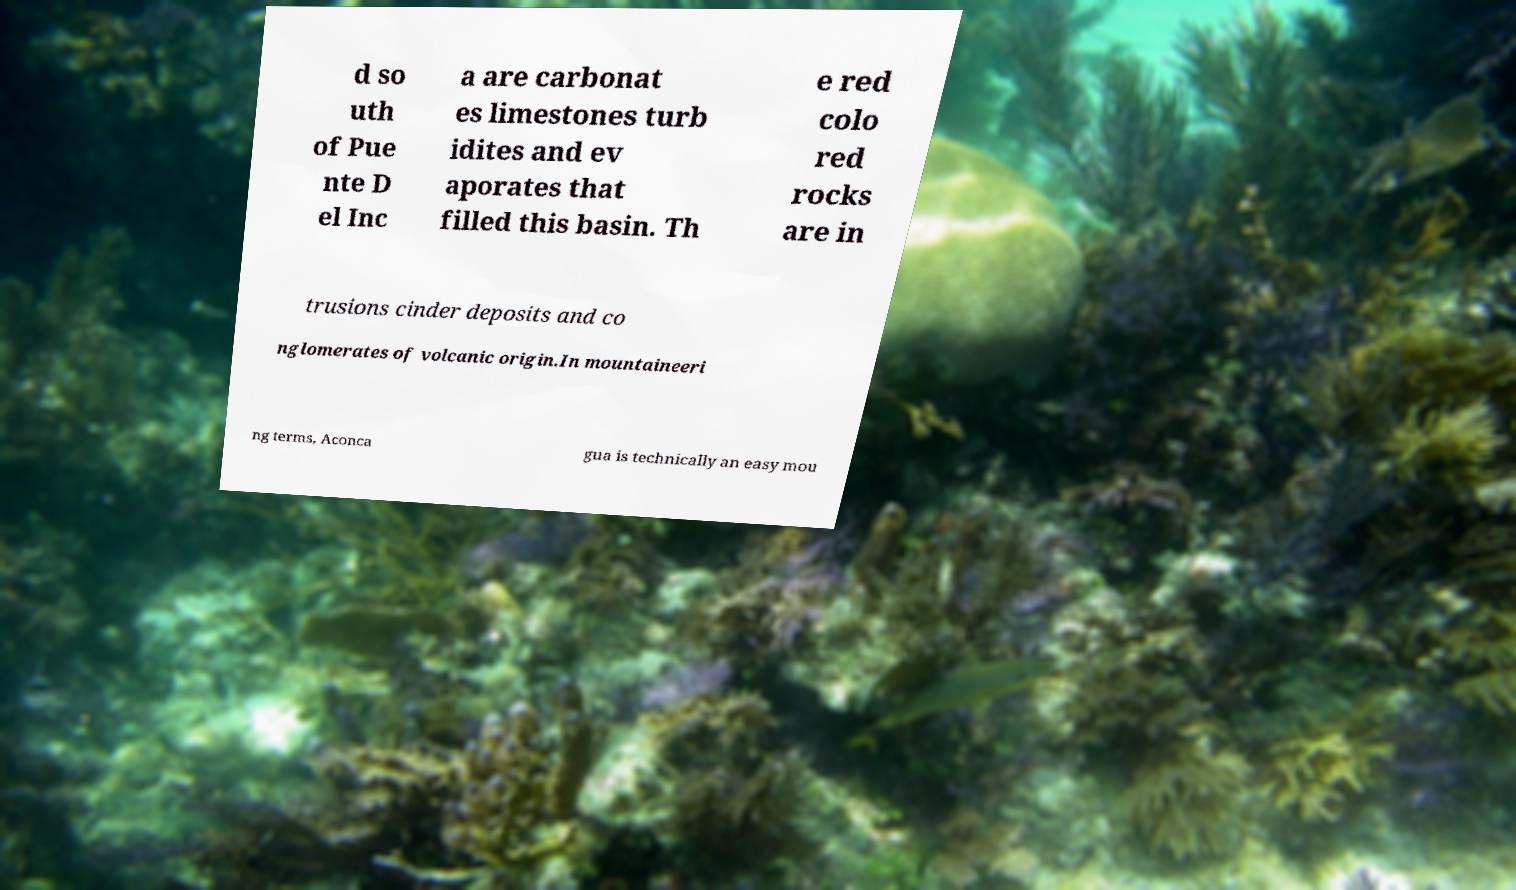Can you accurately transcribe the text from the provided image for me? d so uth of Pue nte D el Inc a are carbonat es limestones turb idites and ev aporates that filled this basin. Th e red colo red rocks are in trusions cinder deposits and co nglomerates of volcanic origin.In mountaineeri ng terms, Aconca gua is technically an easy mou 